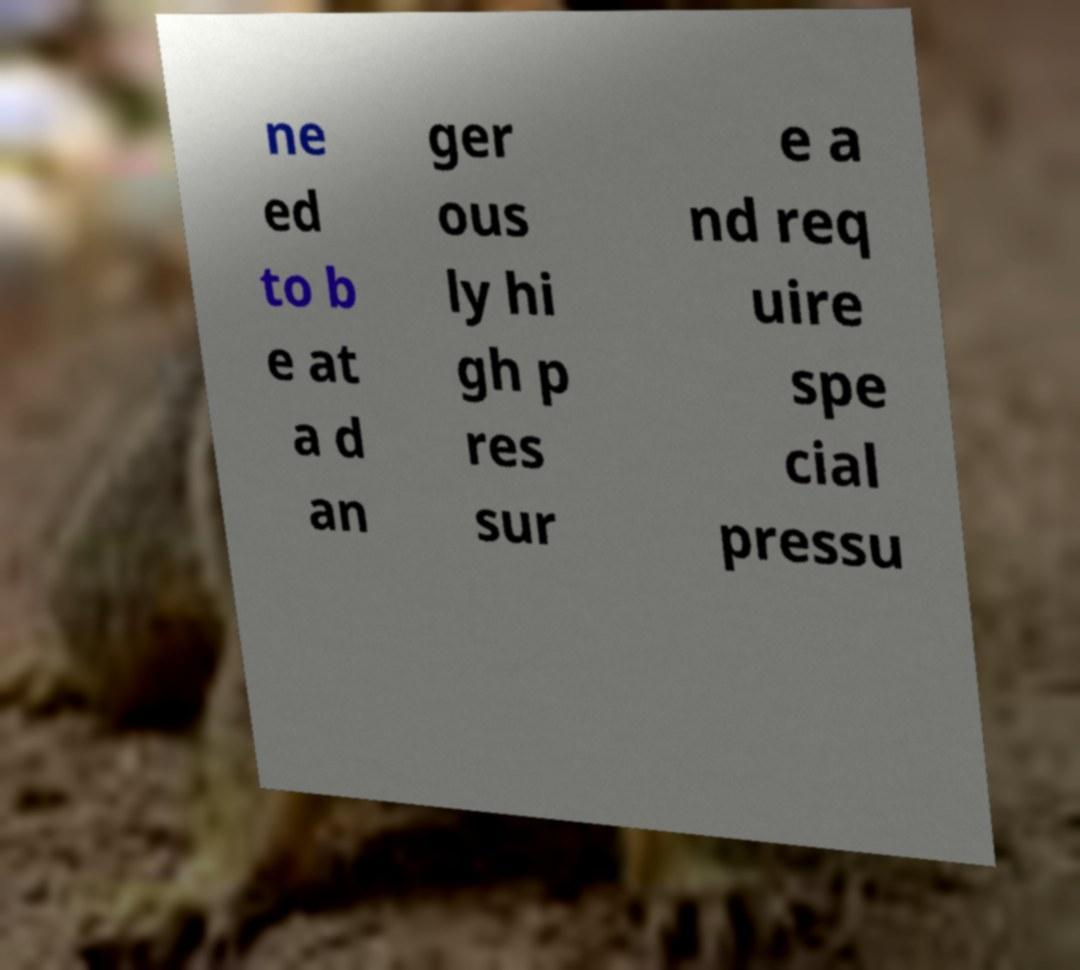Could you extract and type out the text from this image? ne ed to b e at a d an ger ous ly hi gh p res sur e a nd req uire spe cial pressu 